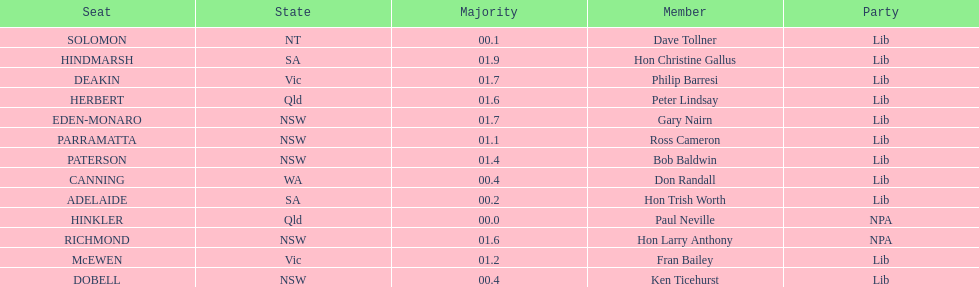What is the total of seats? 13. 